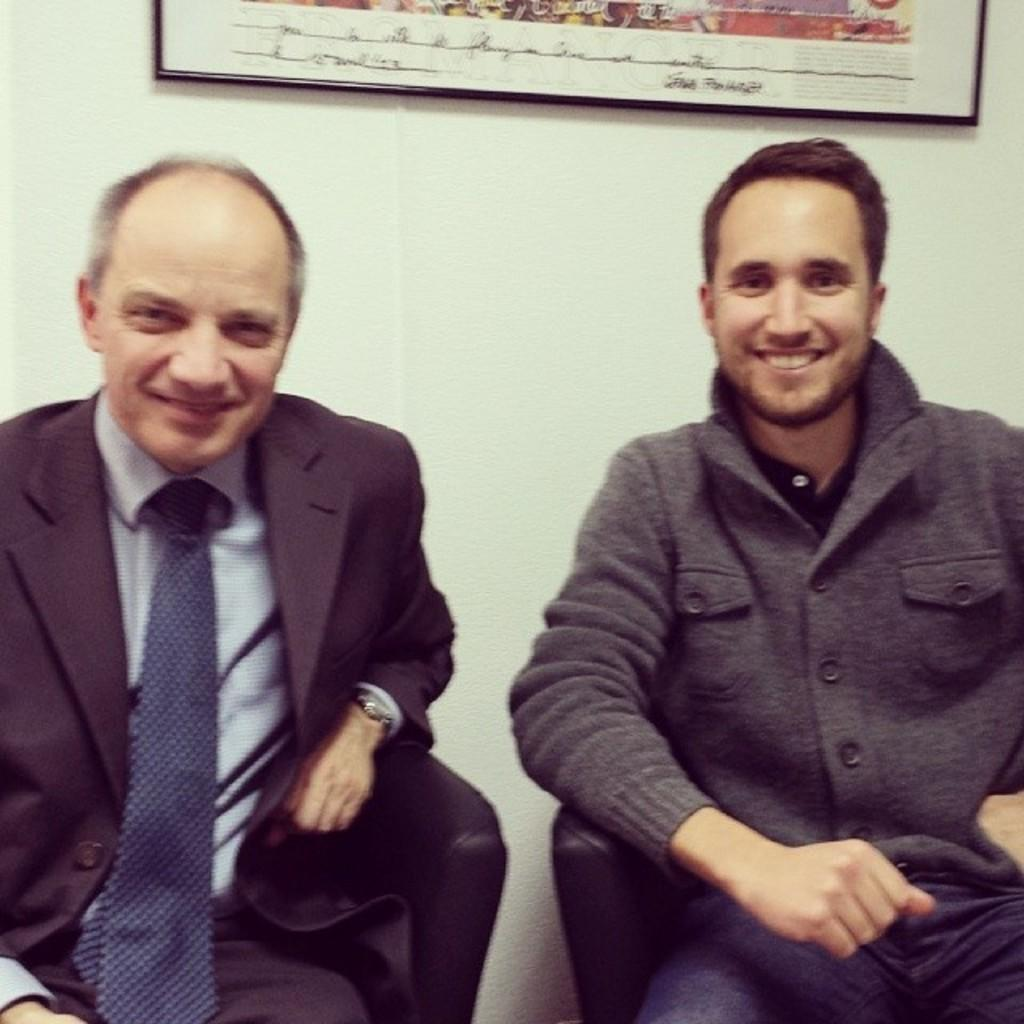How many people are in the image? There are two men in the image. What are the men doing in the image? The men are sitting on chairs and watching and smiling. What can be seen in the background of the image? There is a wall and a photo frame in the background of the image. What type of letter is the servant delivering to the men in the image? There is no servant or letter present in the image. 